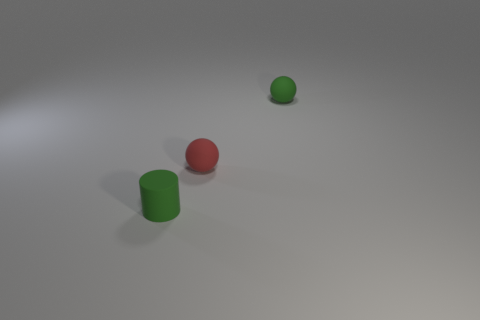Add 3 red shiny cylinders. How many objects exist? 6 Subtract all balls. How many objects are left? 1 Add 1 tiny balls. How many tiny balls are left? 3 Add 2 tiny things. How many tiny things exist? 5 Subtract 0 gray cylinders. How many objects are left? 3 Subtract all tiny cylinders. Subtract all large yellow balls. How many objects are left? 2 